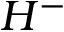<formula> <loc_0><loc_0><loc_500><loc_500>H ^ { - }</formula> 